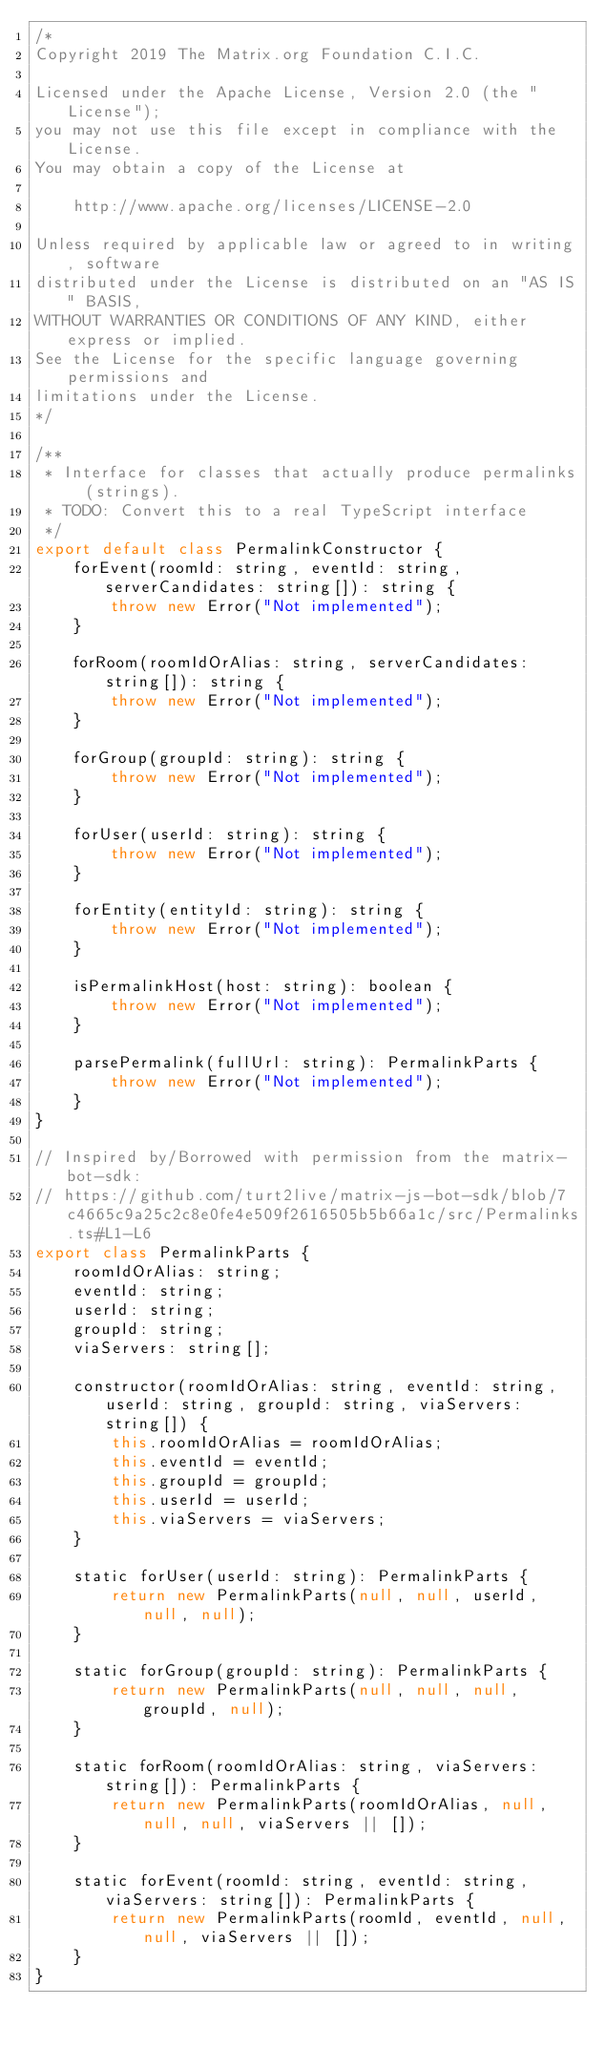<code> <loc_0><loc_0><loc_500><loc_500><_JavaScript_>/*
Copyright 2019 The Matrix.org Foundation C.I.C.

Licensed under the Apache License, Version 2.0 (the "License");
you may not use this file except in compliance with the License.
You may obtain a copy of the License at

    http://www.apache.org/licenses/LICENSE-2.0

Unless required by applicable law or agreed to in writing, software
distributed under the License is distributed on an "AS IS" BASIS,
WITHOUT WARRANTIES OR CONDITIONS OF ANY KIND, either express or implied.
See the License for the specific language governing permissions and
limitations under the License.
*/

/**
 * Interface for classes that actually produce permalinks (strings).
 * TODO: Convert this to a real TypeScript interface
 */
export default class PermalinkConstructor {
    forEvent(roomId: string, eventId: string, serverCandidates: string[]): string {
        throw new Error("Not implemented");
    }

    forRoom(roomIdOrAlias: string, serverCandidates: string[]): string {
        throw new Error("Not implemented");
    }

    forGroup(groupId: string): string {
        throw new Error("Not implemented");
    }

    forUser(userId: string): string {
        throw new Error("Not implemented");
    }

    forEntity(entityId: string): string {
        throw new Error("Not implemented");
    }

    isPermalinkHost(host: string): boolean {
        throw new Error("Not implemented");
    }

    parsePermalink(fullUrl: string): PermalinkParts {
        throw new Error("Not implemented");
    }
}

// Inspired by/Borrowed with permission from the matrix-bot-sdk:
// https://github.com/turt2live/matrix-js-bot-sdk/blob/7c4665c9a25c2c8e0fe4e509f2616505b5b66a1c/src/Permalinks.ts#L1-L6
export class PermalinkParts {
    roomIdOrAlias: string;
    eventId: string;
    userId: string;
    groupId: string;
    viaServers: string[];

    constructor(roomIdOrAlias: string, eventId: string, userId: string, groupId: string, viaServers: string[]) {
        this.roomIdOrAlias = roomIdOrAlias;
        this.eventId = eventId;
        this.groupId = groupId;
        this.userId = userId;
        this.viaServers = viaServers;
    }

    static forUser(userId: string): PermalinkParts {
        return new PermalinkParts(null, null, userId, null, null);
    }

    static forGroup(groupId: string): PermalinkParts {
        return new PermalinkParts(null, null, null, groupId, null);
    }

    static forRoom(roomIdOrAlias: string, viaServers: string[]): PermalinkParts {
        return new PermalinkParts(roomIdOrAlias, null, null, null, viaServers || []);
    }

    static forEvent(roomId: string, eventId: string, viaServers: string[]): PermalinkParts {
        return new PermalinkParts(roomId, eventId, null, null, viaServers || []);
    }
}
</code> 